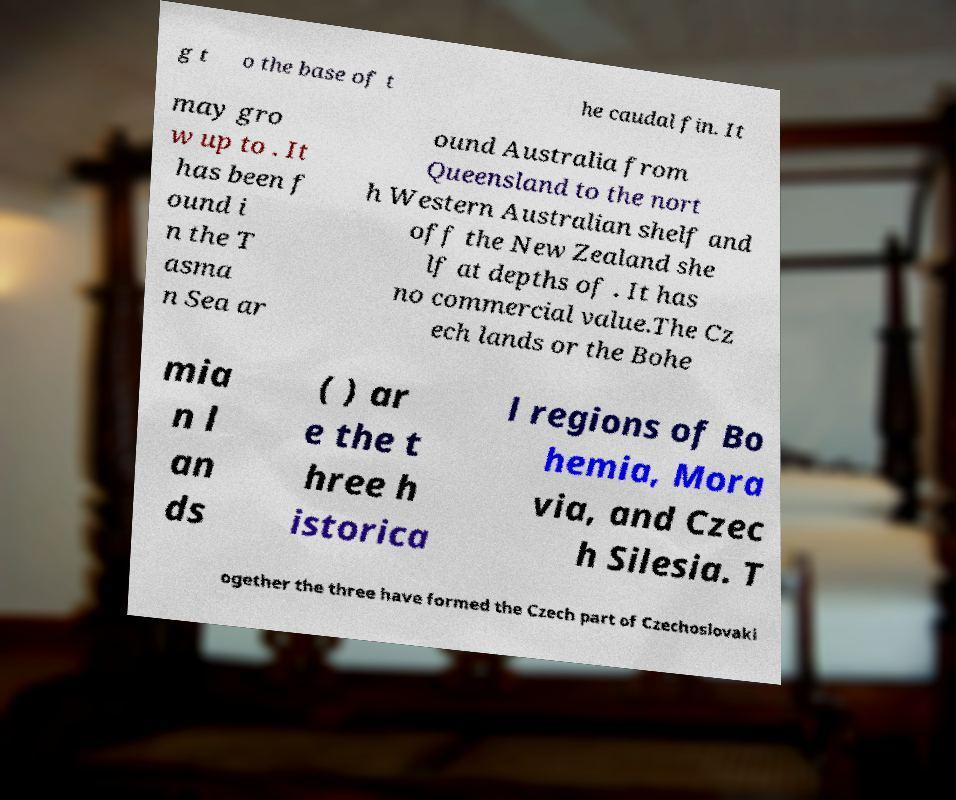There's text embedded in this image that I need extracted. Can you transcribe it verbatim? g t o the base of t he caudal fin. It may gro w up to . It has been f ound i n the T asma n Sea ar ound Australia from Queensland to the nort h Western Australian shelf and off the New Zealand she lf at depths of . It has no commercial value.The Cz ech lands or the Bohe mia n l an ds ( ) ar e the t hree h istorica l regions of Bo hemia, Mora via, and Czec h Silesia. T ogether the three have formed the Czech part of Czechoslovaki 